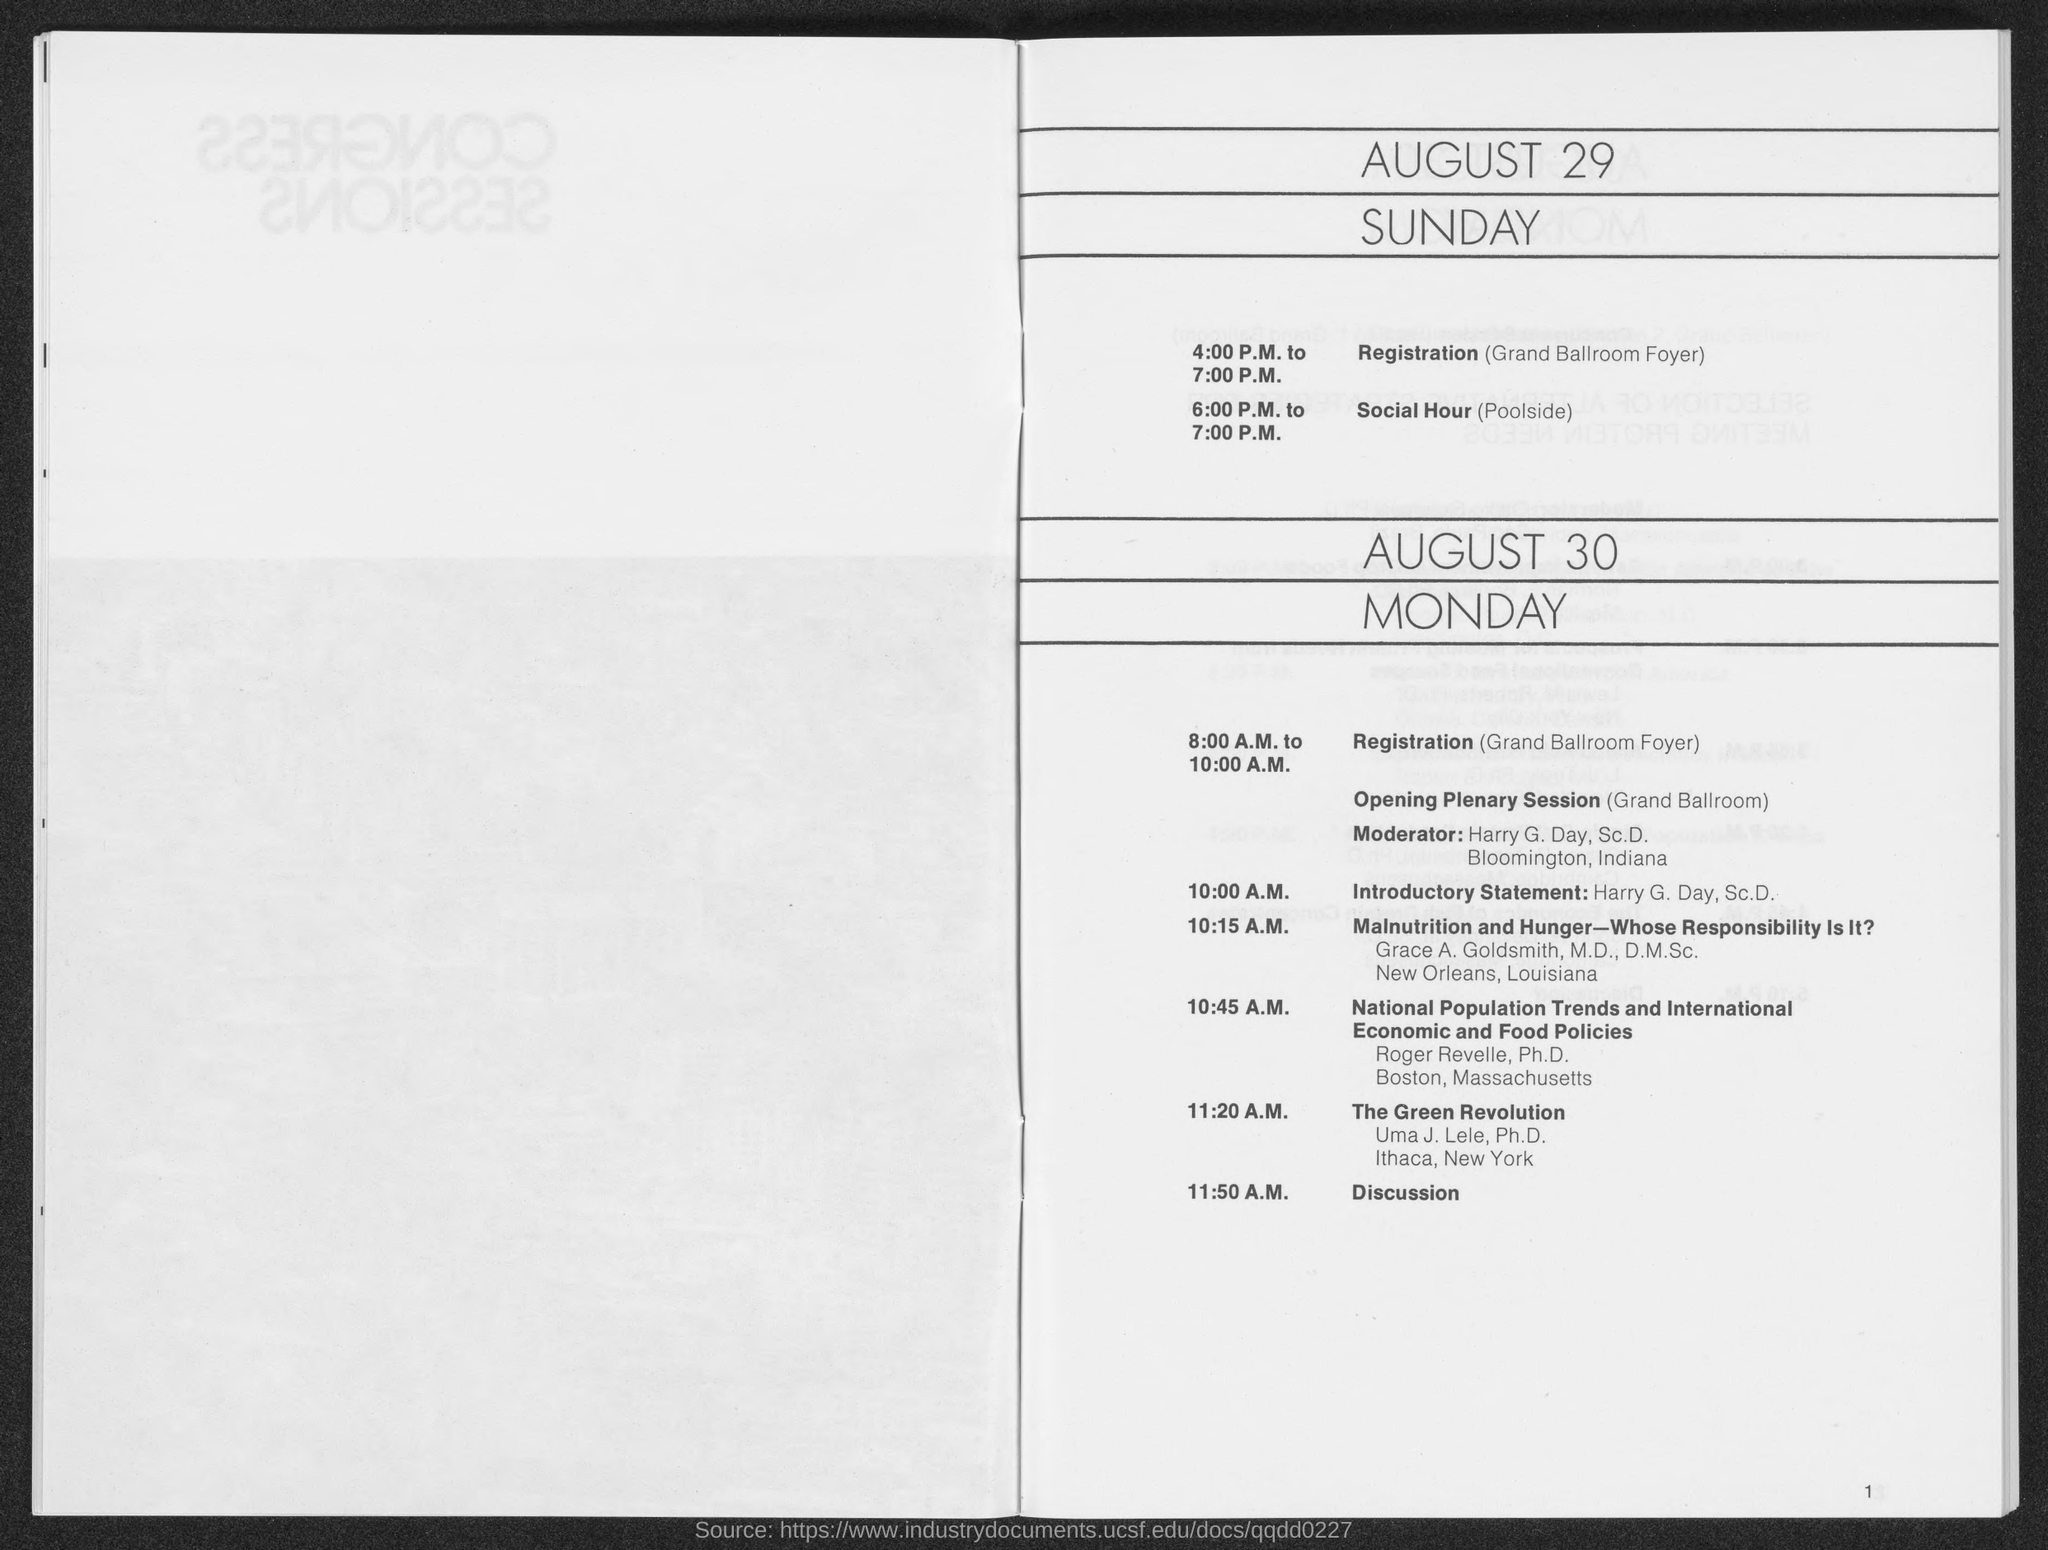Mention a couple of crucial points in this snapshot. The registration specified on August 30 will take place from 8:00 A.M. to 10:00 A.M. The session after "The Green Revolution" is a discussion about the topic of the session. At 6:00 P.M. to 7:00 P.M., the session is Social Hour. The registration timings for August 29 are from 4:00 PM to 7:00 PM. 